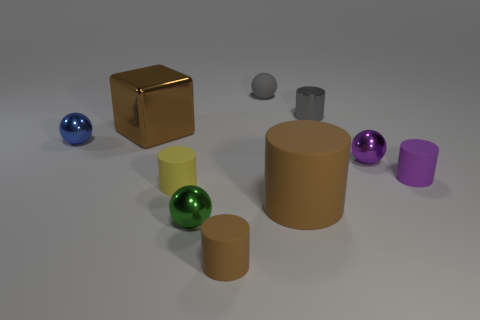Subtract all small gray cylinders. How many cylinders are left? 4 Subtract 2 cylinders. How many cylinders are left? 3 Subtract all gray cylinders. How many cylinders are left? 4 Subtract all purple spheres. Subtract all red blocks. How many spheres are left? 3 Subtract all blocks. How many objects are left? 9 Subtract 0 green cylinders. How many objects are left? 10 Subtract all cyan balls. Subtract all tiny green objects. How many objects are left? 9 Add 8 gray balls. How many gray balls are left? 9 Add 9 purple metallic blocks. How many purple metallic blocks exist? 9 